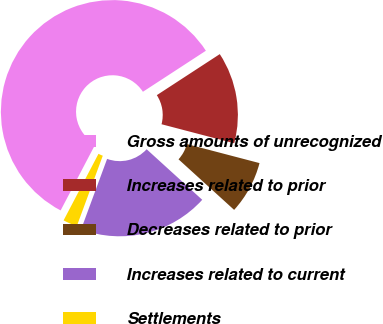Convert chart to OTSL. <chart><loc_0><loc_0><loc_500><loc_500><pie_chart><fcel>Gross amounts of unrecognized<fcel>Increases related to prior<fcel>Decreases related to prior<fcel>Increases related to current<fcel>Settlements<nl><fcel>58.12%<fcel>13.27%<fcel>7.67%<fcel>18.88%<fcel>2.06%<nl></chart> 